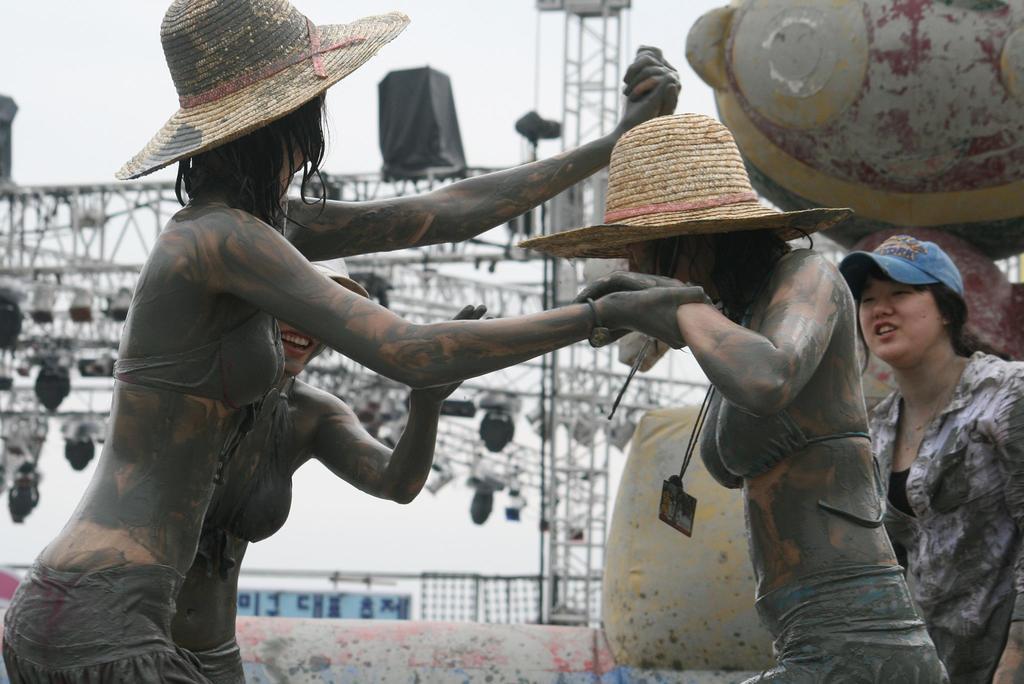Could you give a brief overview of what you see in this image? In this image I can see few people are standing and I can see all of them are wearing caps. In the background I can see metal rods and I can see number of lights. 